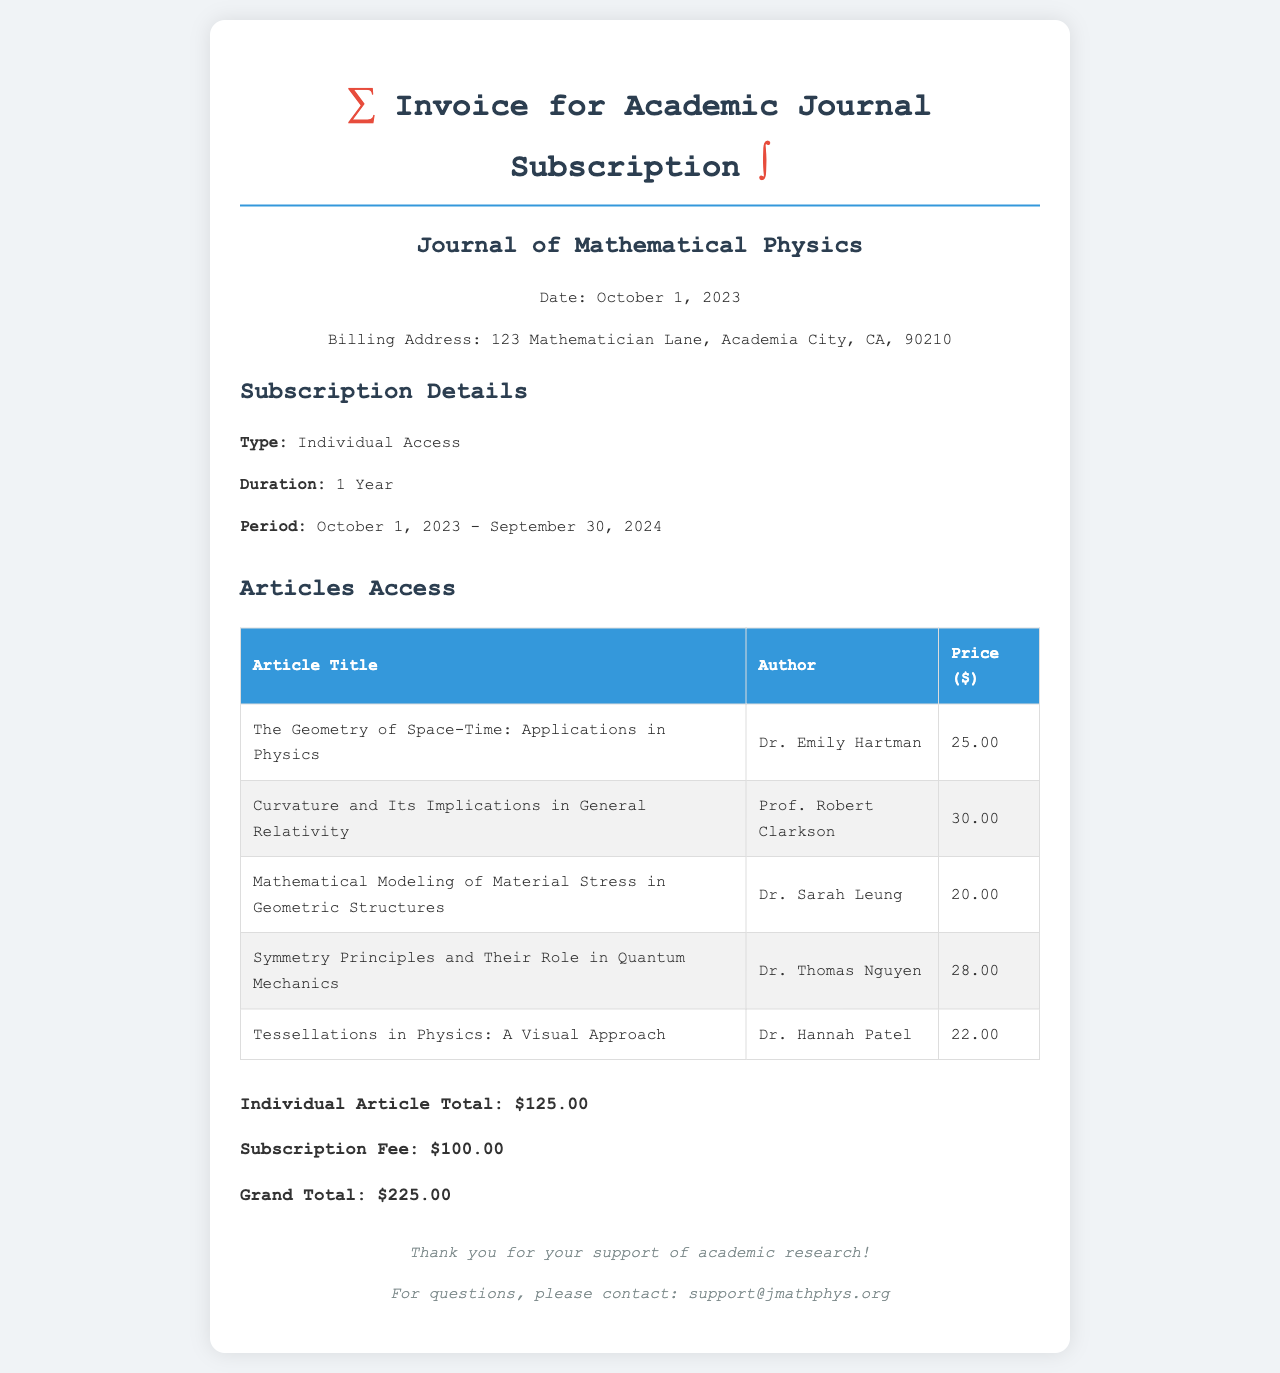What is the name of the journal? The name of the journal is provided at the top of the document, which is the "Journal of Mathematical Physics."
Answer: Journal of Mathematical Physics What is the date of the invoice? The date of the invoice is mentioned in the header section, specifically as October 1, 2023.
Answer: October 1, 2023 Who is the author of the article "Geometry of Space-Time: Applications in Physics"? The document lists the author alongside the article title, which is Dr. Emily Hartman.
Answer: Dr. Emily Hartman What is the subscription fee? The subscription fee is specified in the total section of the document, which amounts to $100.00.
Answer: $100.00 How much is the total for individual articles? The total for individual articles is noted in the document as $125.00.
Answer: $125.00 What is the grand total for the invoice? The grand total is provided at the end of the document, stated as $225.00.
Answer: $225.00 What is the billing address? The billing address is mentioned in the document: 123 Mathematician Lane, Academia City, CA, 90210.
Answer: 123 Mathematician Lane, Academia City, CA, 90210 Which article costs the most? By comparing the prices in the article list, "Curvature and Its Implications in General Relativity" is the highest at $30.00.
Answer: Curvature and Its Implications in General Relativity What is the duration of the subscription? The duration of the subscription is explicitly stated in the subscription details as 1 Year.
Answer: 1 Year 